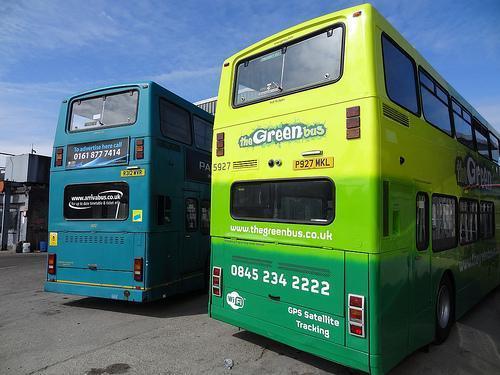How many buses?
Give a very brief answer. 2. How many windows on the back of each bus?
Give a very brief answer. 2. 